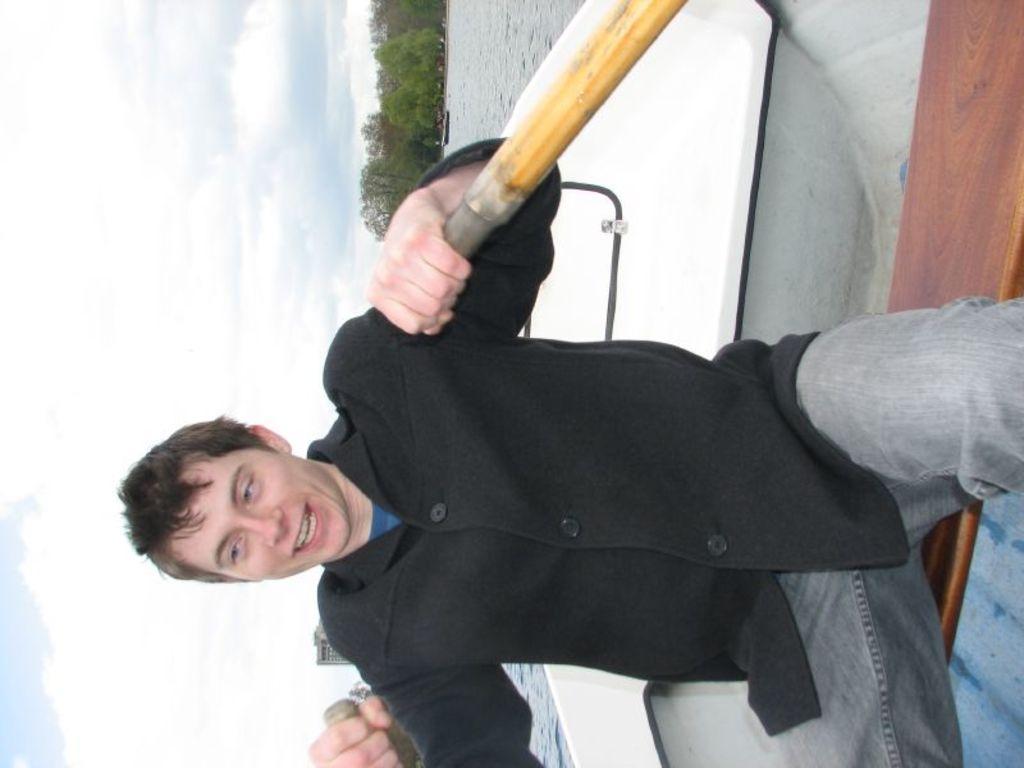Describe this image in one or two sentences. In this image we can see a person sailing on a boat. There are trees and water. In the background we can see cloudy sky. 